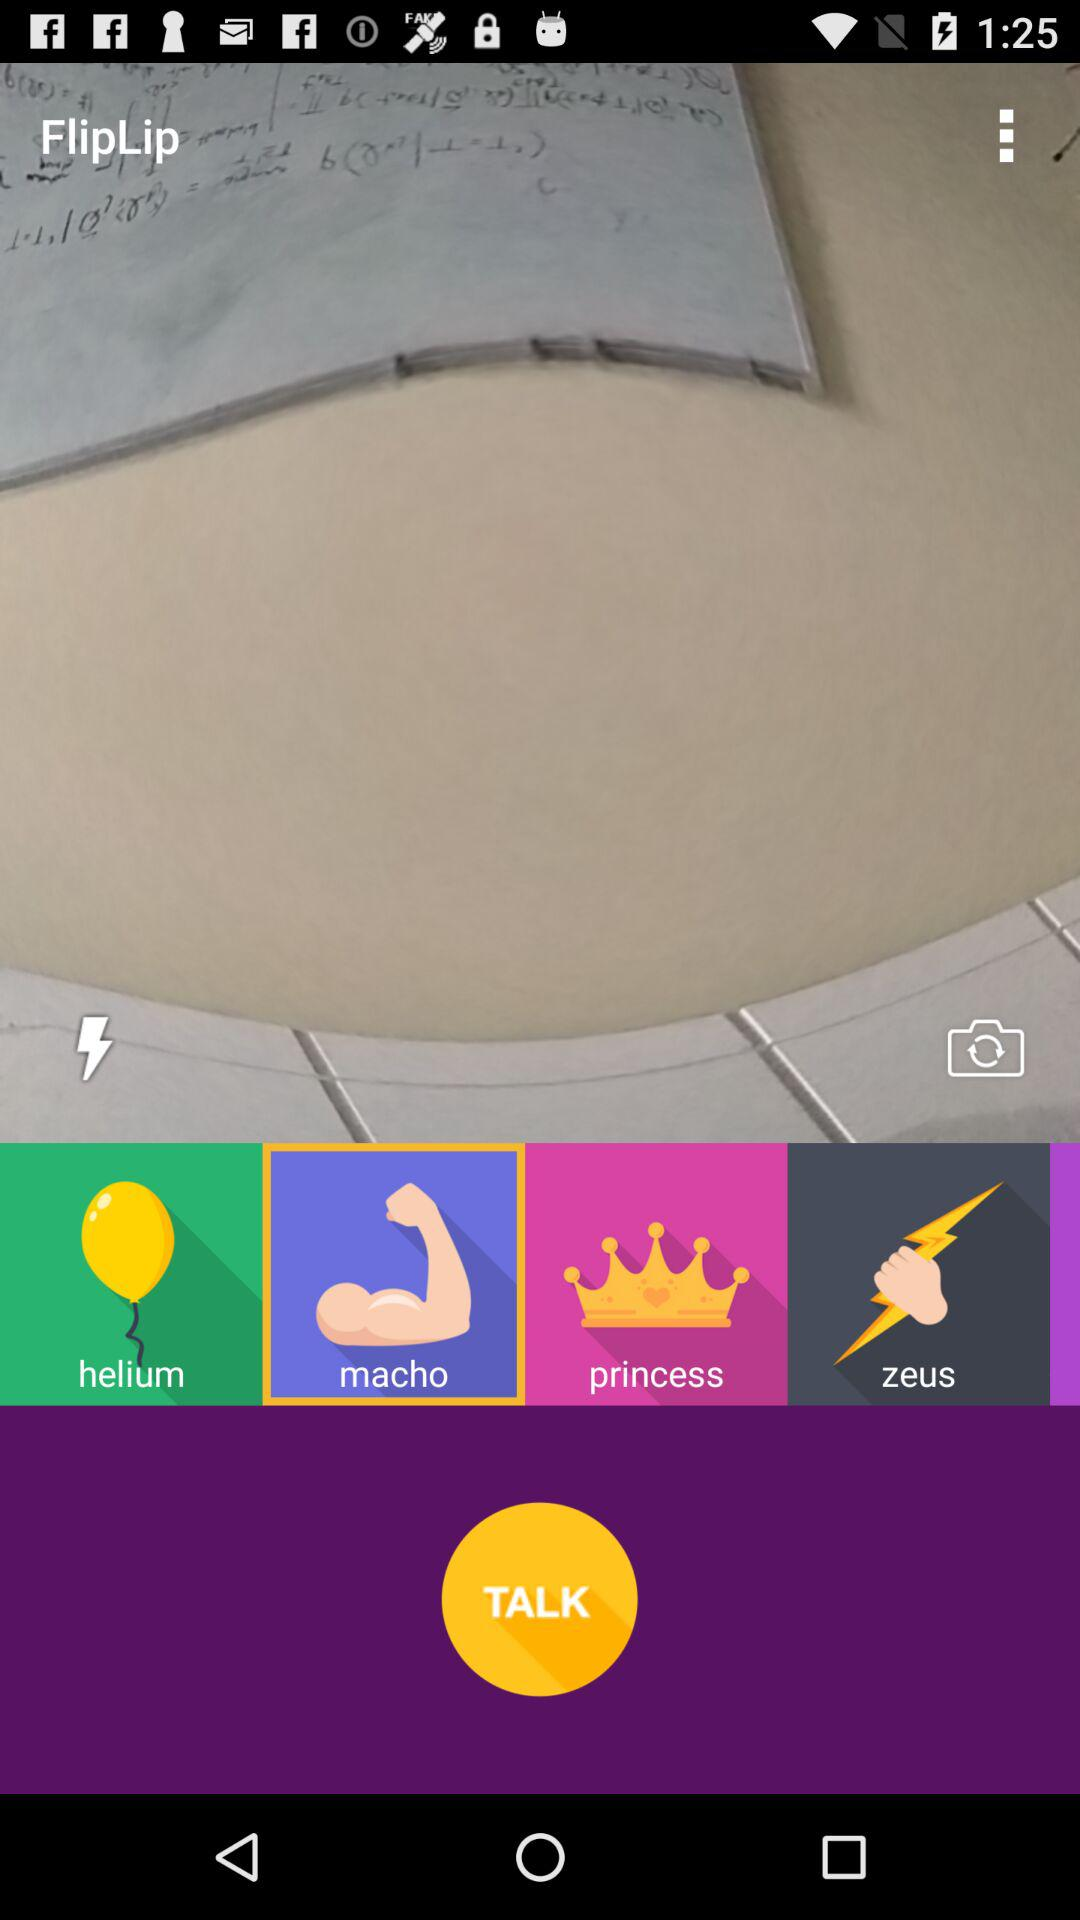What is the name of the application? The name of the application is "FlipLip". 